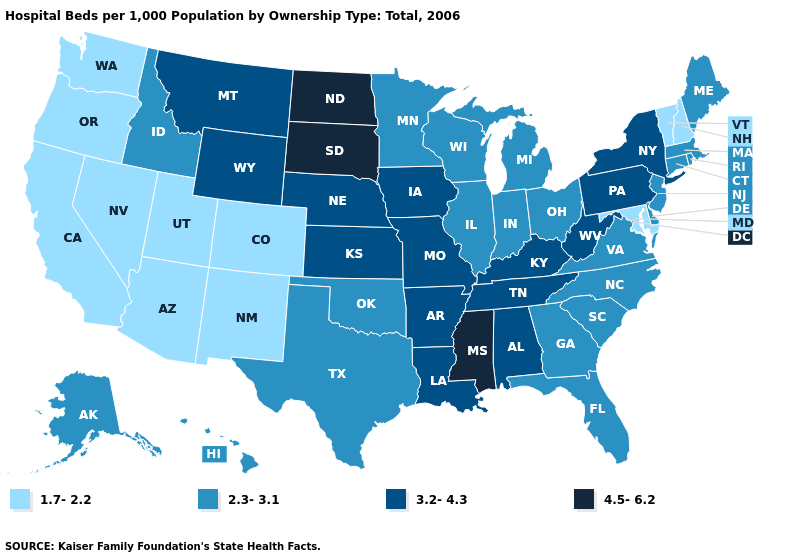What is the value of Connecticut?
Be succinct. 2.3-3.1. Which states have the lowest value in the USA?
Concise answer only. Arizona, California, Colorado, Maryland, Nevada, New Hampshire, New Mexico, Oregon, Utah, Vermont, Washington. Does the map have missing data?
Give a very brief answer. No. Which states have the lowest value in the USA?
Answer briefly. Arizona, California, Colorado, Maryland, Nevada, New Hampshire, New Mexico, Oregon, Utah, Vermont, Washington. Does California have the highest value in the West?
Concise answer only. No. Does South Dakota have the highest value in the USA?
Write a very short answer. Yes. What is the value of Rhode Island?
Quick response, please. 2.3-3.1. Is the legend a continuous bar?
Give a very brief answer. No. What is the value of Oklahoma?
Answer briefly. 2.3-3.1. Which states have the lowest value in the MidWest?
Write a very short answer. Illinois, Indiana, Michigan, Minnesota, Ohio, Wisconsin. What is the value of Illinois?
Keep it brief. 2.3-3.1. What is the value of Louisiana?
Short answer required. 3.2-4.3. What is the lowest value in the Northeast?
Concise answer only. 1.7-2.2. How many symbols are there in the legend?
Be succinct. 4. Does Maryland have a lower value than Indiana?
Concise answer only. Yes. 